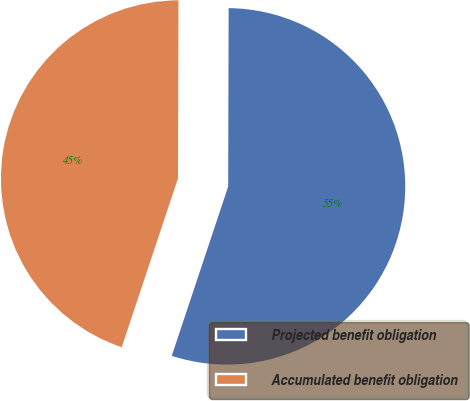<chart> <loc_0><loc_0><loc_500><loc_500><pie_chart><fcel>Projected benefit obligation<fcel>Accumulated benefit obligation<nl><fcel>55.08%<fcel>44.92%<nl></chart> 